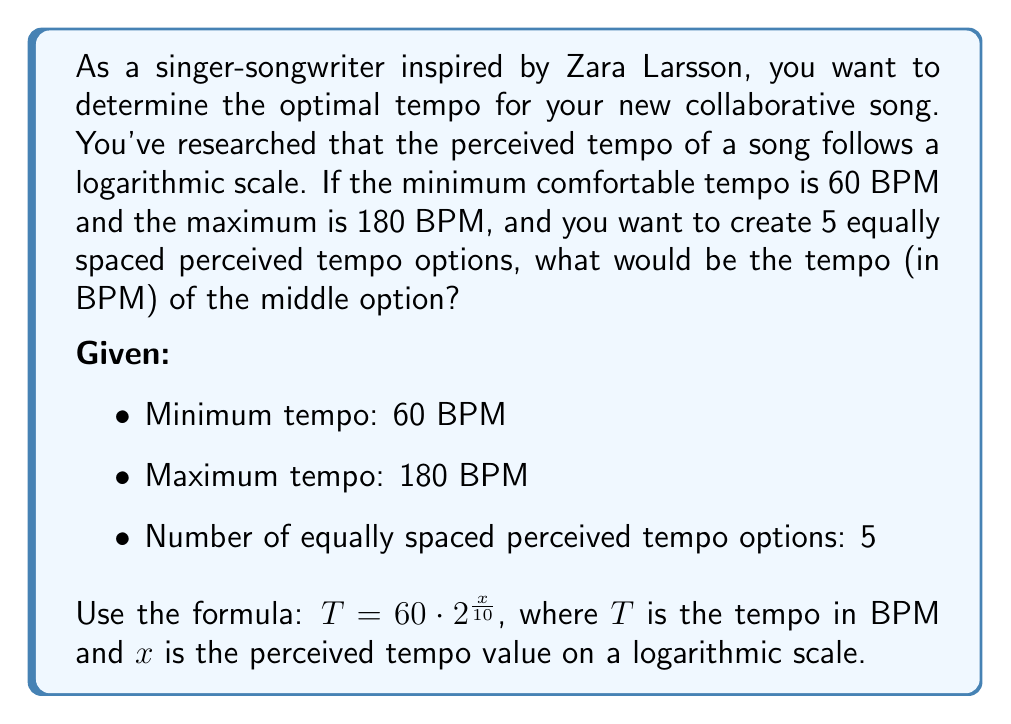Show me your answer to this math problem. To solve this problem, we'll follow these steps:

1) First, we need to find the perceived tempo values ($x$) for the minimum and maximum tempos:

   For 60 BPM: $60 = 60 \cdot 2^{\frac{x_{\text{min}}}{10}}$
   $1 = 2^{\frac{x_{\text{min}}}{10}}$
   $x_{\text{min}} = 0$

   For 180 BPM: $180 = 60 \cdot 2^{\frac{x_{\text{max}}}{10}}$
   $3 = 2^{\frac{x_{\text{max}}}{10}}$
   $\log_2 3 = \frac{x_{\text{max}}}{10}$
   $x_{\text{max}} = 10 \log_2 3 \approx 15.85$

2) Now, we need to divide this range into 5 equal parts:

   Step size = $\frac{x_{\text{max}} - x_{\text{min}}}{4} = \frac{15.85 - 0}{4} \approx 3.96$

3) The middle option will be at the 3rd step (0, 3.96, 7.92, 11.88, 15.85):

   $x_{\text{middle}} = 7.92$

4) Now we can calculate the tempo for this middle option:

   $T_{\text{middle}} = 60 \cdot 2^{\frac{7.92}{10}}$

5) Calculating this:

   $T_{\text{middle}} = 60 \cdot 2^{0.792} \approx 104.4$ BPM
Answer: The tempo of the middle option is approximately 104.4 BPM. 